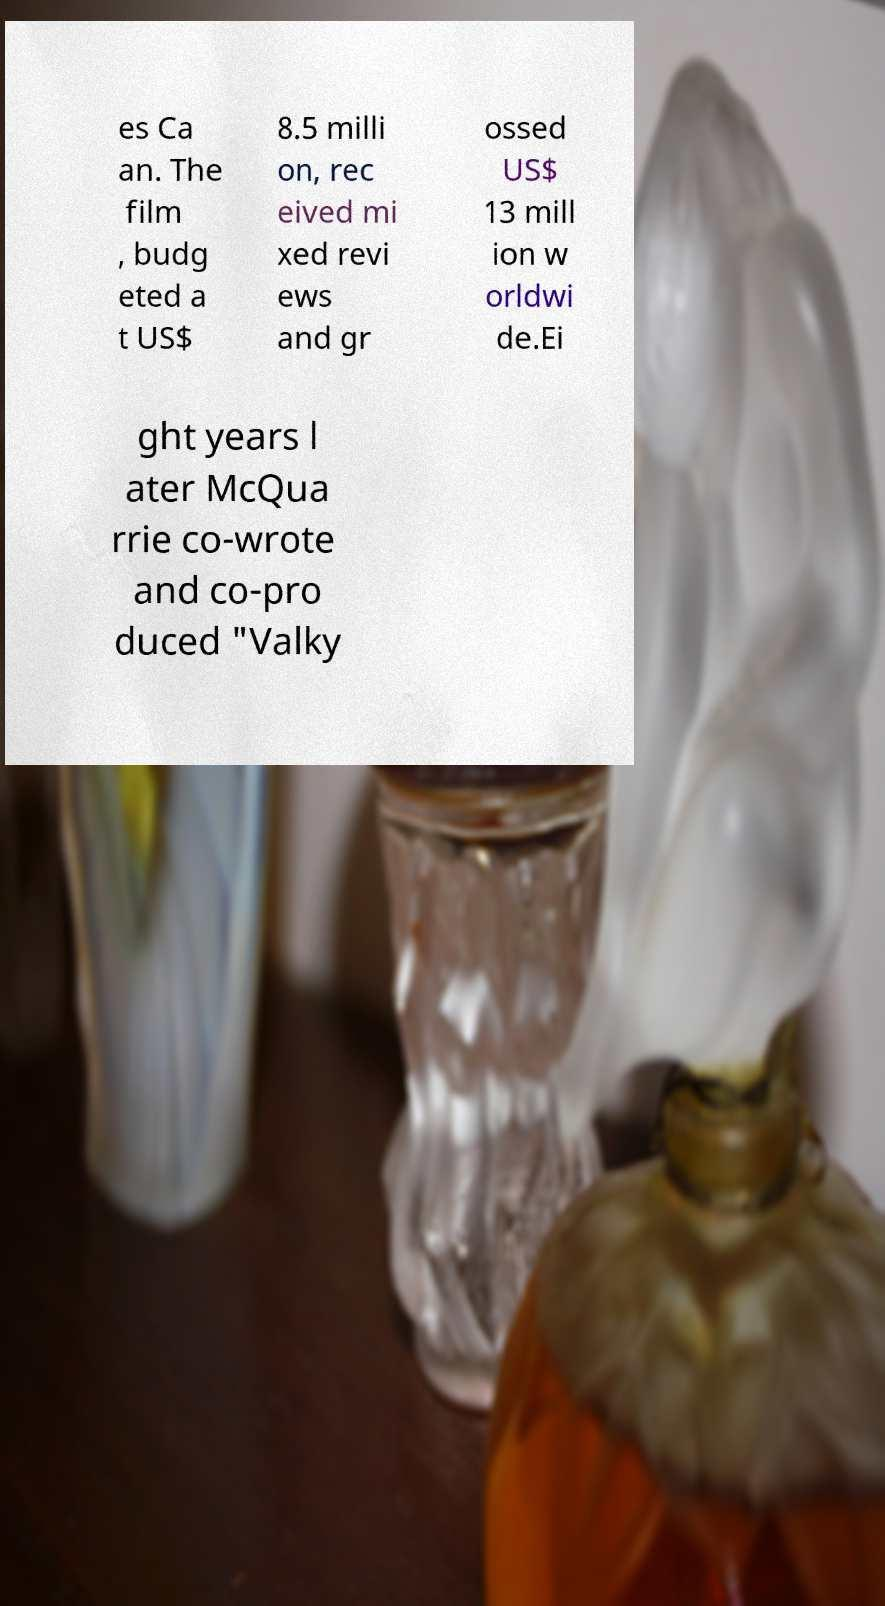There's text embedded in this image that I need extracted. Can you transcribe it verbatim? es Ca an. The film , budg eted a t US$ 8.5 milli on, rec eived mi xed revi ews and gr ossed US$ 13 mill ion w orldwi de.Ei ght years l ater McQua rrie co-wrote and co-pro duced "Valky 